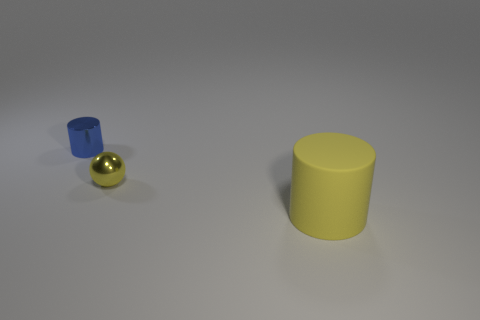Add 1 big cylinders. How many objects exist? 4 Subtract 1 spheres. How many spheres are left? 0 Subtract all balls. How many objects are left? 2 Subtract all small yellow metallic things. Subtract all blue metallic cylinders. How many objects are left? 1 Add 3 yellow spheres. How many yellow spheres are left? 4 Add 1 tiny green rubber cylinders. How many tiny green rubber cylinders exist? 1 Subtract 0 cyan blocks. How many objects are left? 3 Subtract all green balls. Subtract all gray cubes. How many balls are left? 1 